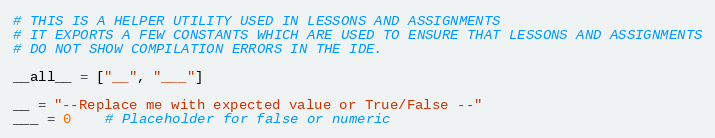Convert code to text. <code><loc_0><loc_0><loc_500><loc_500><_Python_># THIS IS A HELPER UTILITY USED IN LESSONS AND ASSIGNMENTS
# IT EXPORTS A FEW CONSTANTS WHICH ARE USED TO ENSURE THAT LESSONS AND ASSIGNMENTS
# DO NOT SHOW COMPILATION ERRORS IN THE IDE.

__all__ = ["__", "___"]

__ = "--Replace me with expected value or True/False --"
___ = 0    # Placeholder for false or numeric</code> 